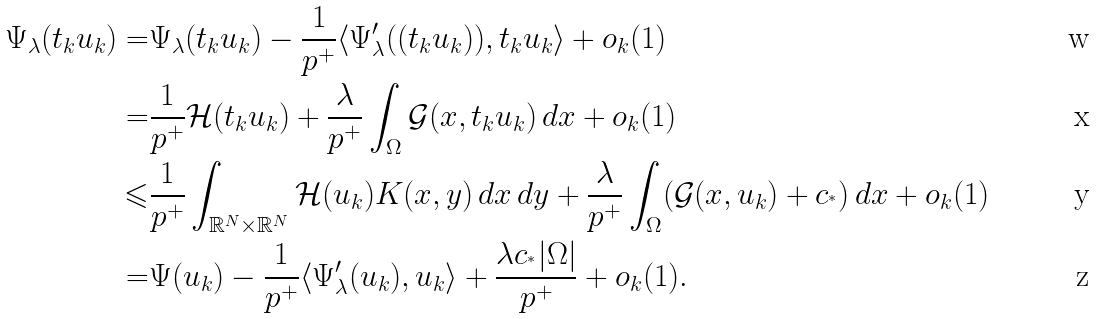Convert formula to latex. <formula><loc_0><loc_0><loc_500><loc_500>\Psi _ { \lambda } ( t _ { k } u _ { k } ) = & \Psi _ { \lambda } ( t _ { k } u _ { k } ) - \frac { 1 } { p ^ { + } } \langle \Psi _ { \lambda } ^ { \prime } ( ( t _ { k } u _ { k } ) ) , t _ { k } u _ { k } \rangle + o _ { k } ( 1 ) \\ = & \frac { 1 } { p ^ { + } } \mathcal { H } ( t _ { k } u _ { k } ) + \frac { \lambda } { p ^ { + } } \int _ { \Omega } \mathcal { G } ( x , t _ { k } u _ { k } ) \, d x + o _ { k } ( 1 ) \\ \leqslant & \frac { 1 } { p ^ { + } } \int _ { \mathbb { R } ^ { N } \times \mathbb { R } ^ { N } } \mathcal { H } ( u _ { k } ) K ( x , y ) \, d x \, d y + \frac { \lambda } { p ^ { + } } \int _ { \Omega } ( \mathcal { G } ( x , u _ { k } ) + c _ { ^ { * } } ) \, d x + o _ { k } ( 1 ) \\ = & \Psi ( u _ { k } ) - \frac { 1 } { p ^ { + } } \langle \Psi _ { \lambda } ^ { \prime } ( u _ { k } ) , u _ { k } \rangle + \frac { \lambda c _ { ^ { * } } | \Omega | } { p ^ { + } } + o _ { k } ( 1 ) .</formula> 